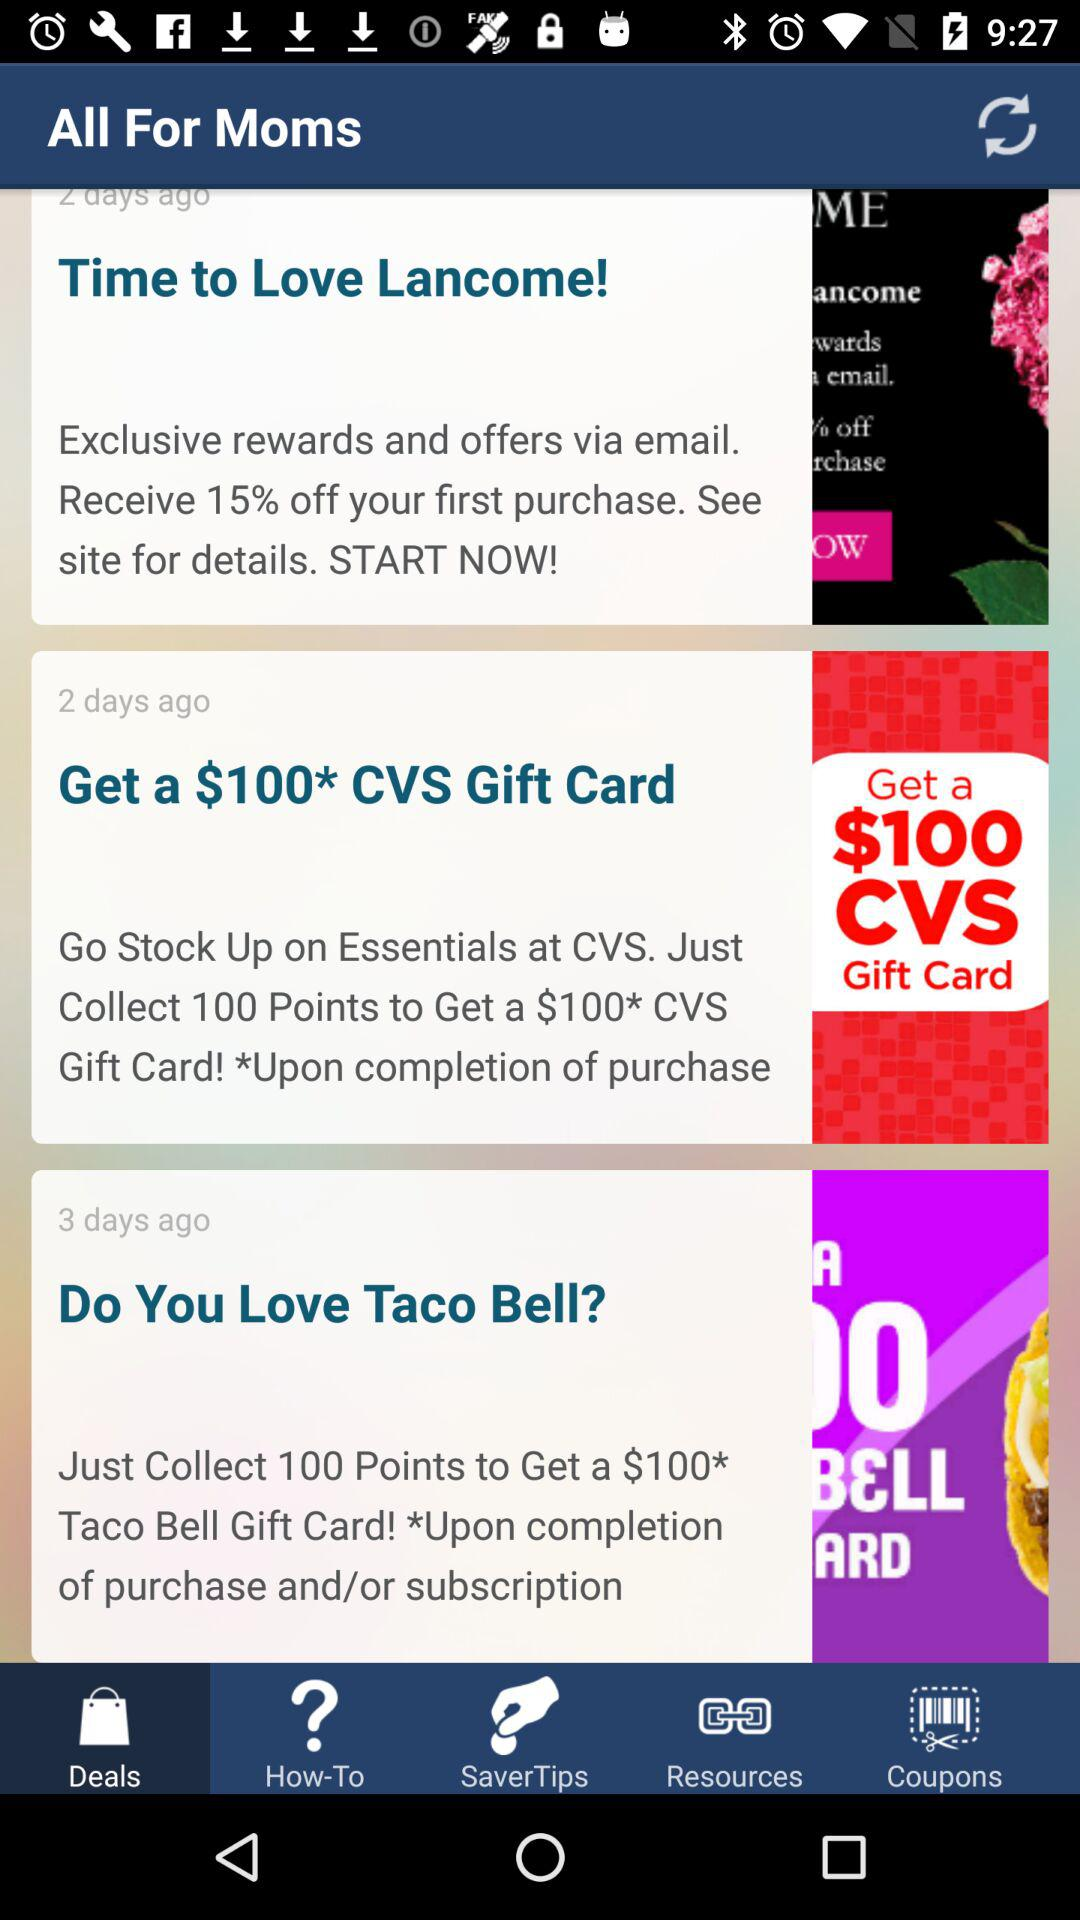How many points do I need to get a $100 CVS gift card?
Answer the question using a single word or phrase. 100 